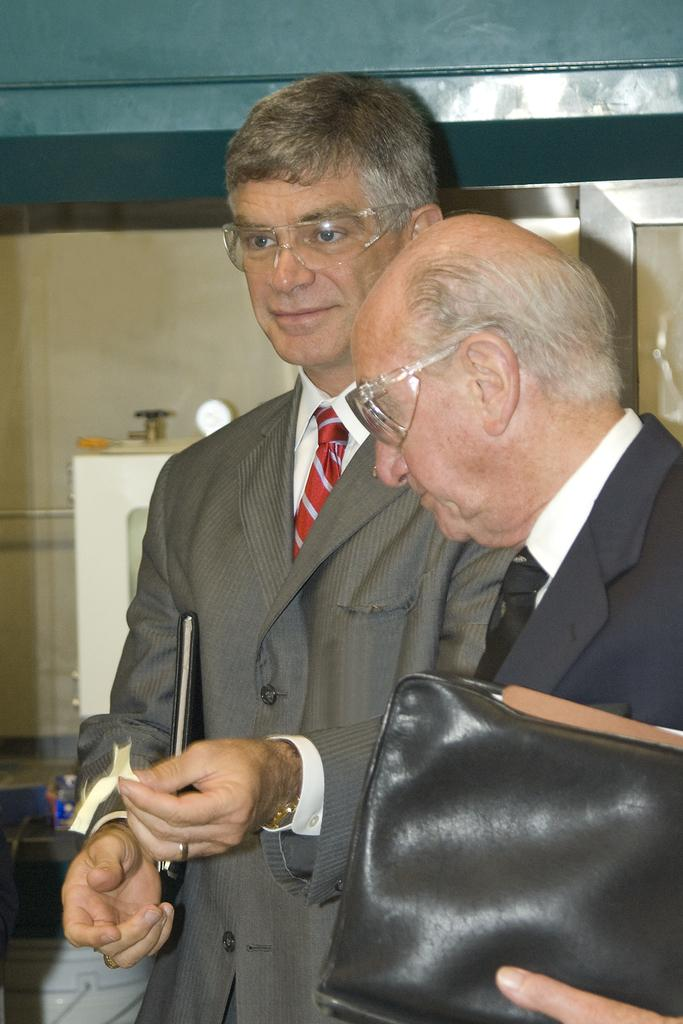How many people are in the image? There are two men in the image. What are the men holding in their hands? The men are holding objects in their hands. Can you describe the surroundings of the men in the image? There may be a wall beside the men. Are there any cobwebs visible in the image? There is no mention of cobwebs in the provided facts, so we cannot determine if any are present in the image. 